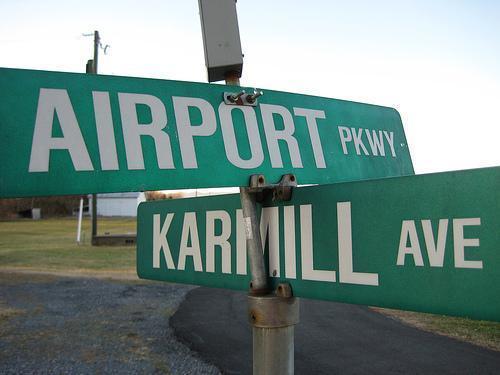How many street signs are there?
Give a very brief answer. 2. 